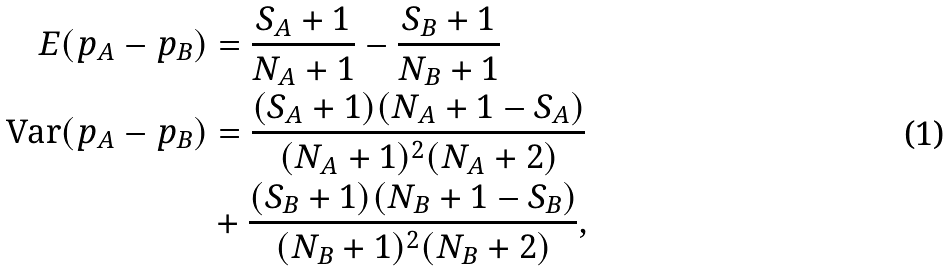<formula> <loc_0><loc_0><loc_500><loc_500>E ( p _ { A } - p _ { B } ) & = \frac { S _ { A } + 1 } { N _ { A } + 1 } - \frac { S _ { B } + 1 } { N _ { B } + 1 } \\ \text {Var} ( p _ { A } - p _ { B } ) & = \frac { ( S _ { A } + 1 ) ( N _ { A } + 1 - S _ { A } ) } { ( N _ { A } + 1 ) ^ { 2 } ( N _ { A } + 2 ) } \\ & + \frac { ( S _ { B } + 1 ) ( N _ { B } + 1 - S _ { B } ) } { ( N _ { B } + 1 ) ^ { 2 } ( N _ { B } + 2 ) } ,</formula> 